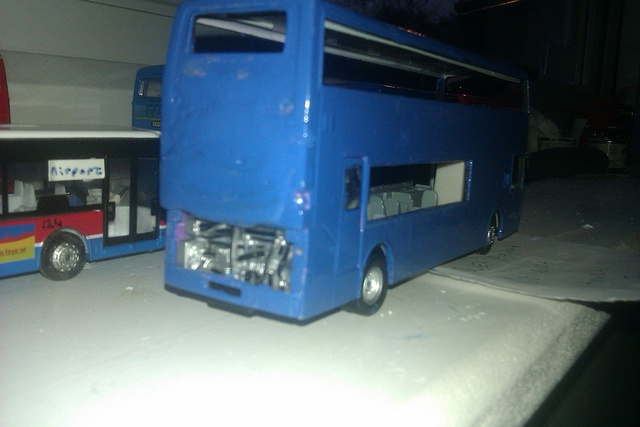Describe the objects in this image and their specific colors. I can see bus in gray, blue, black, and navy tones and bus in gray, black, darkgray, and blue tones in this image. 